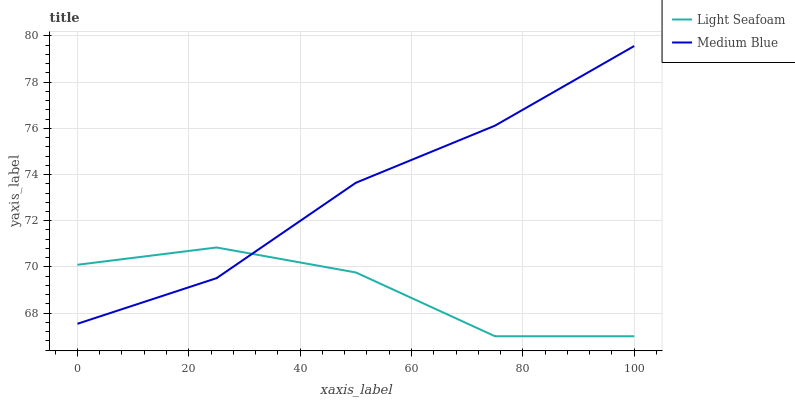Does Light Seafoam have the minimum area under the curve?
Answer yes or no. Yes. Does Medium Blue have the maximum area under the curve?
Answer yes or no. Yes. Does Medium Blue have the minimum area under the curve?
Answer yes or no. No. Is Medium Blue the smoothest?
Answer yes or no. Yes. Is Light Seafoam the roughest?
Answer yes or no. Yes. Is Medium Blue the roughest?
Answer yes or no. No. Does Light Seafoam have the lowest value?
Answer yes or no. Yes. Does Medium Blue have the lowest value?
Answer yes or no. No. Does Medium Blue have the highest value?
Answer yes or no. Yes. Does Light Seafoam intersect Medium Blue?
Answer yes or no. Yes. Is Light Seafoam less than Medium Blue?
Answer yes or no. No. Is Light Seafoam greater than Medium Blue?
Answer yes or no. No. 